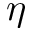Convert formula to latex. <formula><loc_0><loc_0><loc_500><loc_500>\eta</formula> 